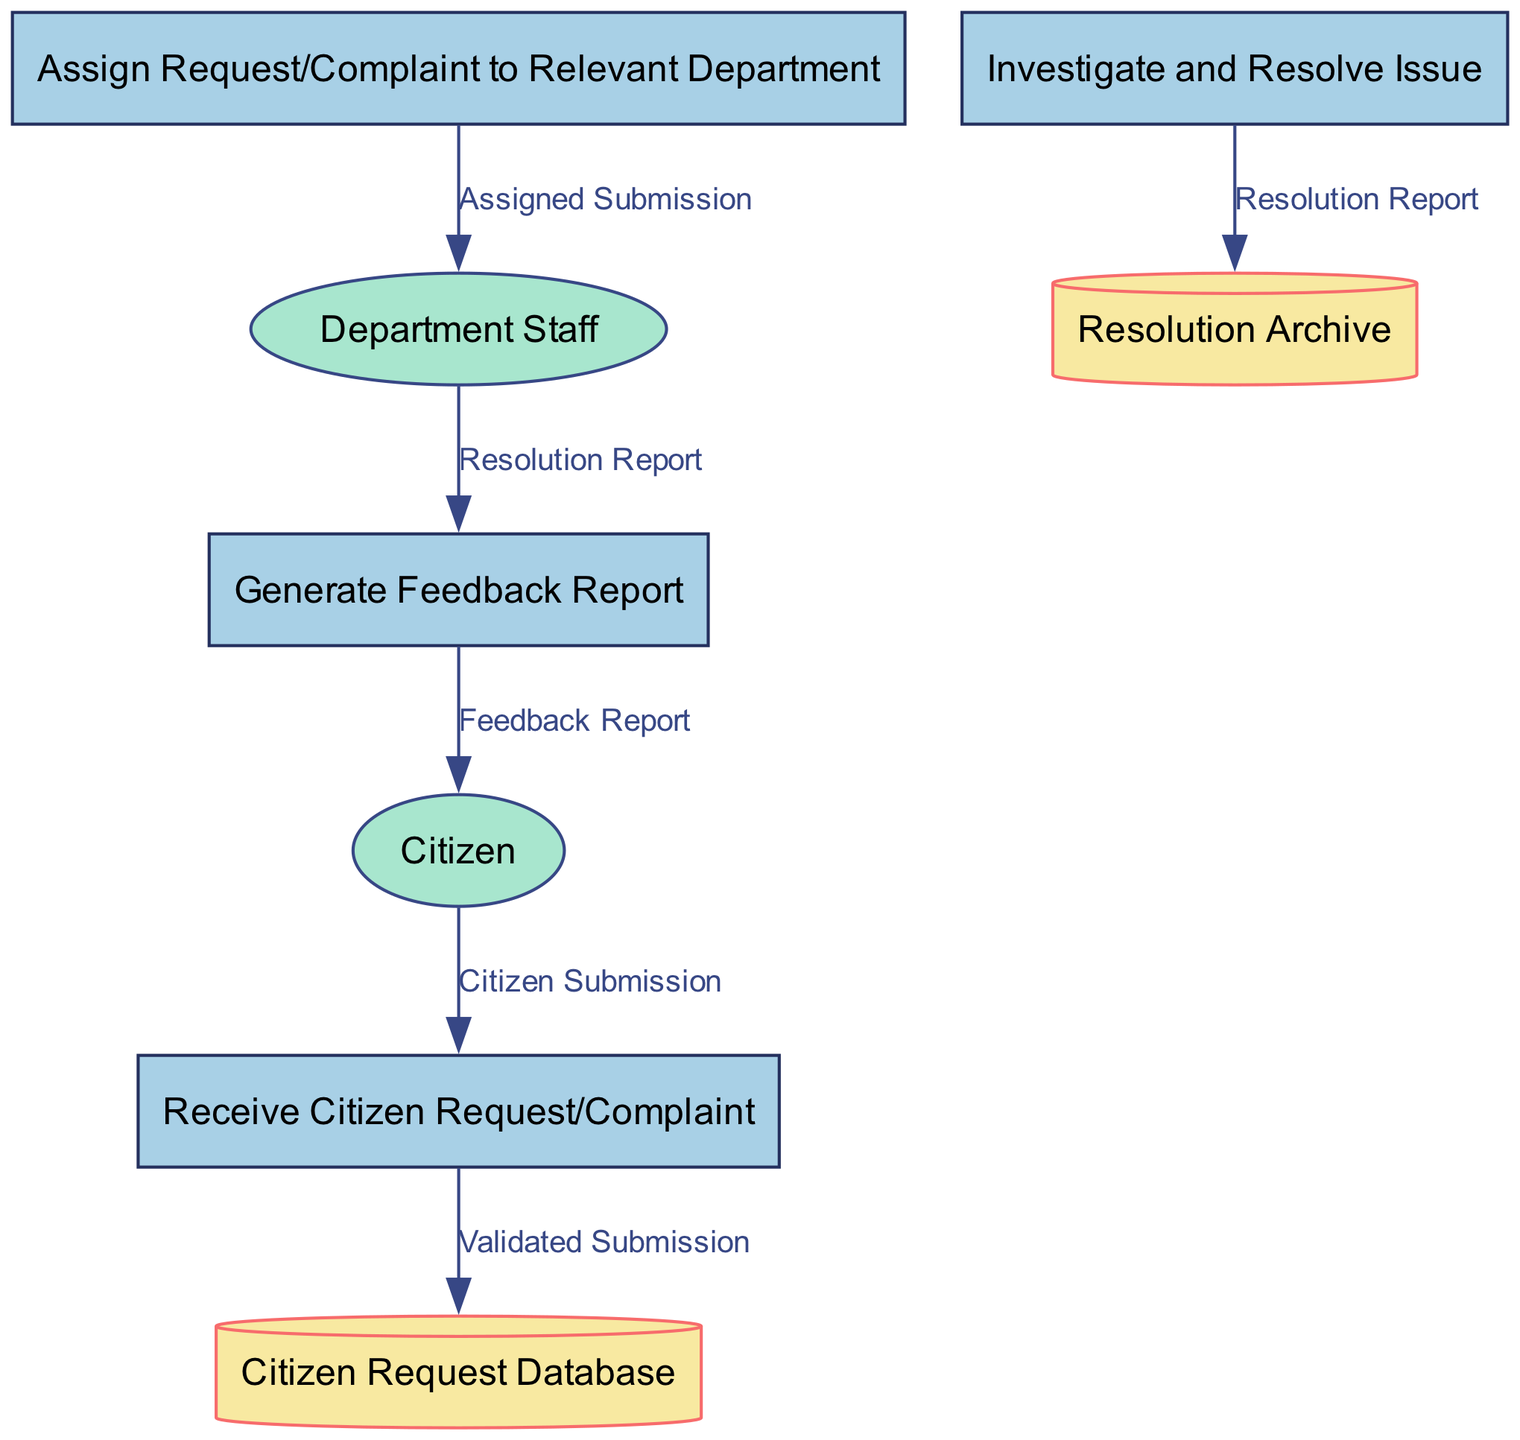What is the first process in the diagram? The first process listed is "Receive Citizen Request/Complaint". It is identified as process number 1 in the diagram.
Answer: Receive Citizen Request/Complaint How many processes are involved in the system? The diagram consists of four processes, each performing different functions in the request and complaint handling system.
Answer: 4 What data store contains citizen requests and complaints? The data store designed to hold citizen requests and complaints is named "Citizen Request Database". This is clearly labeled in the diagram.
Answer: Citizen Request Database Which external entity receives the feedback report? The external entity that receives the feedback report is the "Citizen". This relationship is shown in the diagram where the feedback is directed to the citizen.
Answer: Citizen What is the output of the process "Investigate and Resolve Issue"? The output from the "Investigate and Resolve Issue" process is the "Resolution Report". This is specified as the output of that process in the diagram.
Answer: Resolution Report What process comes after "Assign Request/Complaint to Relevant Department"? Following the "Assign Request/Complaint to Relevant Department", the next process is "Investigate and Resolve Issue". This sequential flow can be traced in the diagram.
Answer: Investigate and Resolve Issue How many data stores exist in the diagram? The diagram features two data stores, which are responsible for handling submissions and resolutions respectively.
Answer: 2 What is the main role of the external entity "Department Staff"? The role of the "Department Staff" is to handle the "Assigned Submission" and produce a "Resolution Report" as their output in the workflow.
Answer: Assigned Submission What type of diagram is represented in the code provided? The diagram generated in the code is a Data Flow Diagram, which illustrates the flow of data and processes involved in handling citizen requests and complaints.
Answer: Data Flow Diagram 